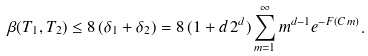<formula> <loc_0><loc_0><loc_500><loc_500>\beta ( T _ { 1 } , T _ { 2 } ) \leq 8 \, ( \delta _ { 1 } + \delta _ { 2 } ) = 8 \, ( 1 + d \, 2 ^ { d } ) \sum _ { m = 1 } ^ { \infty } m ^ { d - 1 } e ^ { - F ( C \, m ) } .</formula> 